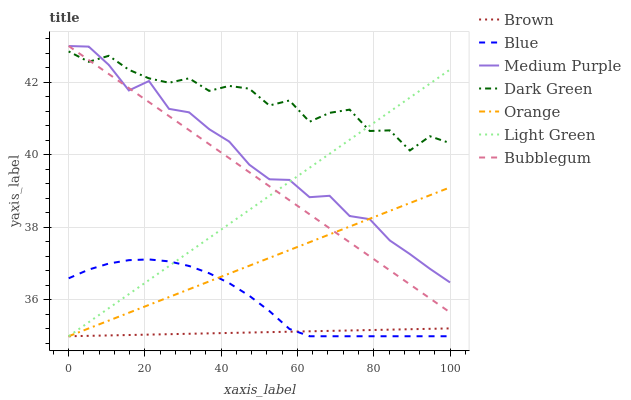Does Brown have the minimum area under the curve?
Answer yes or no. Yes. Does Dark Green have the maximum area under the curve?
Answer yes or no. Yes. Does Bubblegum have the minimum area under the curve?
Answer yes or no. No. Does Bubblegum have the maximum area under the curve?
Answer yes or no. No. Is Light Green the smoothest?
Answer yes or no. Yes. Is Dark Green the roughest?
Answer yes or no. Yes. Is Brown the smoothest?
Answer yes or no. No. Is Brown the roughest?
Answer yes or no. No. Does Blue have the lowest value?
Answer yes or no. Yes. Does Bubblegum have the lowest value?
Answer yes or no. No. Does Medium Purple have the highest value?
Answer yes or no. Yes. Does Brown have the highest value?
Answer yes or no. No. Is Brown less than Bubblegum?
Answer yes or no. Yes. Is Dark Green greater than Blue?
Answer yes or no. Yes. Does Orange intersect Bubblegum?
Answer yes or no. Yes. Is Orange less than Bubblegum?
Answer yes or no. No. Is Orange greater than Bubblegum?
Answer yes or no. No. Does Brown intersect Bubblegum?
Answer yes or no. No. 